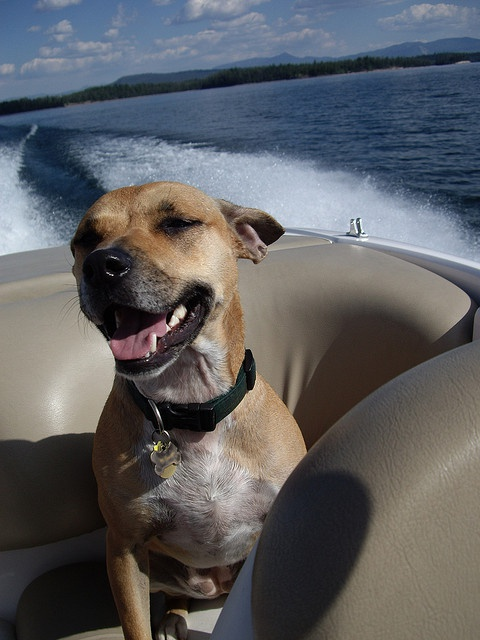Describe the objects in this image and their specific colors. I can see boat in blue, black, gray, and darkgray tones and dog in blue, black, gray, darkgray, and tan tones in this image. 